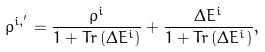<formula> <loc_0><loc_0><loc_500><loc_500>\rho ^ { i , ^ { \prime } } = \frac { \rho ^ { i } } { 1 + T r \left ( \Delta E ^ { i } \right ) } + \frac { \Delta E ^ { i } } { 1 + T r \left ( \Delta E ^ { i } \right ) } ,</formula> 